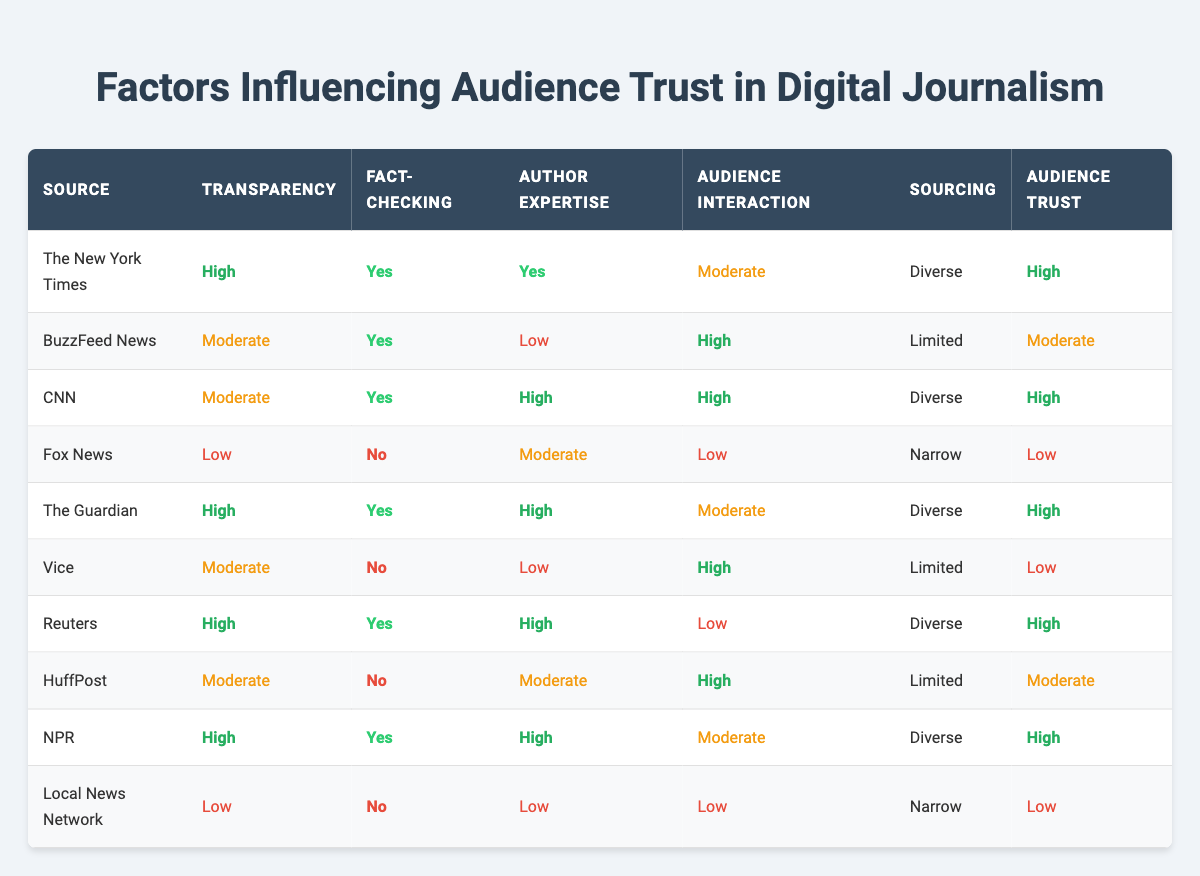What is the transparency level of BuzzFeed News? BuzzFeed News listed under the "Transparency" column shows "Moderate", which is the value presented corresponding to that source.
Answer: Moderate Which source has the highest audience trust? Looking through the "Audience Trust" column, The New York Times, CNN, The Guardian, Reuters, and NPR all have the value "High", indicating these sources have the highest audience trust.
Answer: The New York Times, CNN, The Guardian, Reuters, NPR How many sources are reported to have "Low" author expertise? By scanning the "Author Expertise" column, the sources with "Low" expertise are BuzzFeed News, Vice, Local News Network, totaling 3 sources.
Answer: 3 Is there a source that has "No" fact-checking and "High" audience interaction? By checking the "Fact-checking" column for "No" and the "Audience Interaction" column for "High", Vice and Local News Network do not meet this criterion, as they have "Low" interaction. Thus, the answer is no.
Answer: No What is the average audience trust rating for sources with "High" transparency? The sources with "High" transparency are The New York Times, The Guardian, Reuters, and NPR. All these sources have "High" in the audience trust rating. Therefore, the average will be high since all values are the same.
Answer: High Which source has "Moderate" audience interaction and "Diverse" sourcing? Checking the table, CNN and The Guardian both have "Moderate" audience interaction, but only The Guardian has "Diverse" sourcing, while CNN does not; thus, the source that fits is The Guardian.
Answer: The Guardian How many sources exhibit "High" fact-checking but have "Low" audience interaction? The data indicates that Reuters is the only source with "High" fact-checking and "Low" audience interaction.
Answer: 1 What combination of transparency and audience trust applies to a source with "Limited" sourcing? The data shows BuzzFeed News and Vice with "Limited" sourcing. Both of these have "Moderate" trust and "Moderate" transparency, indicating they share this combination.
Answer: Moderate transparency and moderate trust Are there any sources with "High" author expertise and "No" fact-checking? A review of the rows shows that all sources with "High" author expertise (The New York Times, CNN, The Guardian, Reuters, and NPR) have "Yes" for fact-checking, leading to the conclusion that no such sources exist in the table.
Answer: No 